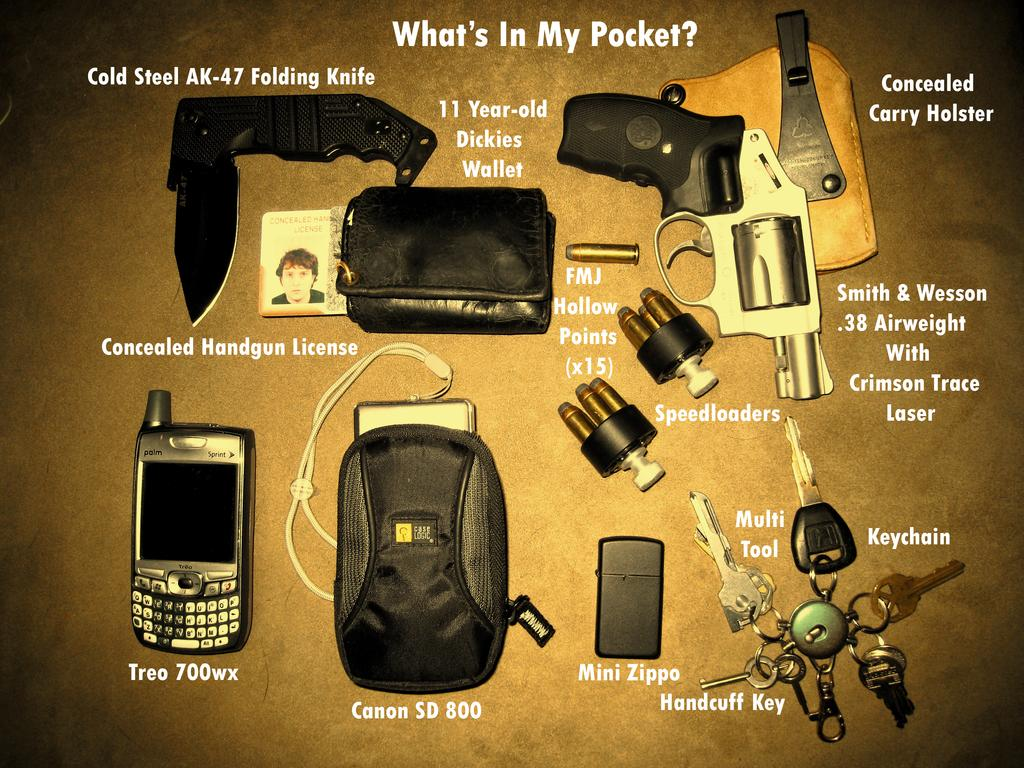<image>
Render a clear and concise summary of the photo. Multiple items displayed on a table includng a CanonSD 800, Mini Zippo, and Treo 700wx. 